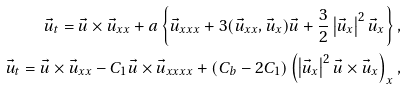Convert formula to latex. <formula><loc_0><loc_0><loc_500><loc_500>\vec { u } _ { t } = \vec { u } \times \vec { u } _ { x x } + a \left \{ \vec { u } _ { x x x } + 3 ( \vec { u } _ { x x } , \vec { u } _ { x } ) \vec { u } + \frac { 3 } { 2 } \left | \vec { u } _ { x } \right | ^ { 2 } \vec { u } _ { x } \right \} , \\ \vec { u } _ { t } = \vec { u } \times \vec { u } _ { x x } - C _ { 1 } \vec { u } \times \vec { u } _ { x x x x } + ( C _ { b } - 2 C _ { 1 } ) \left ( \left | \vec { u } _ { x } \right | ^ { 2 } \vec { u } \times \vec { u } _ { x } \right ) _ { x } ,</formula> 